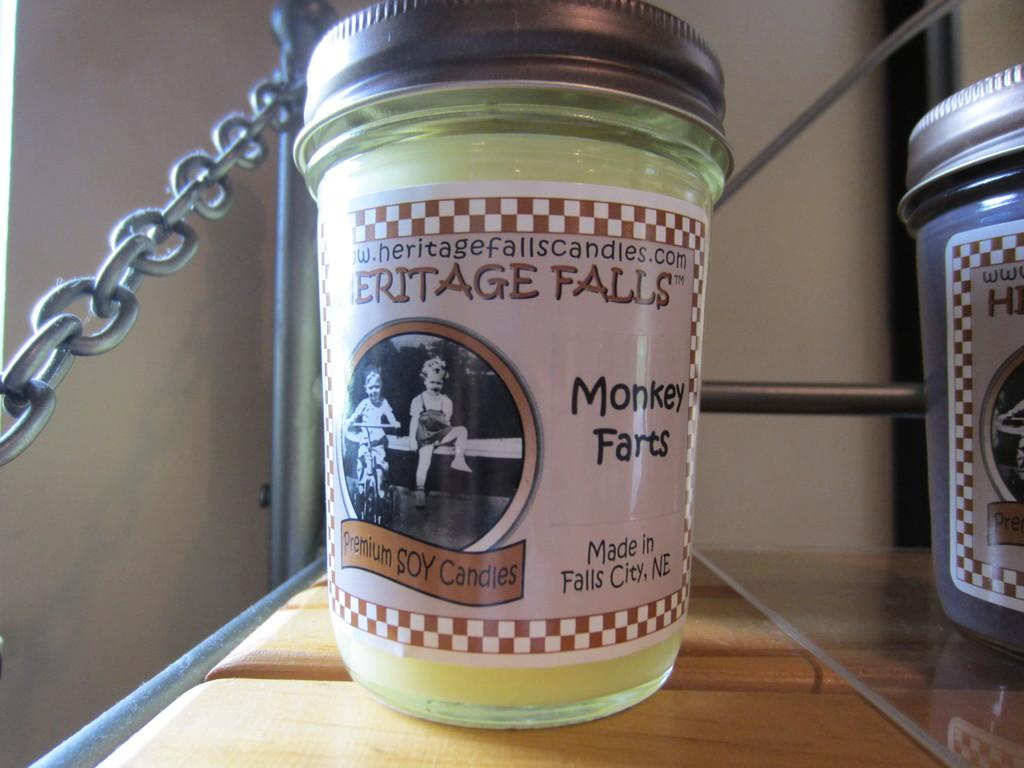Provide a one-sentence caption for the provided image. A Monkey Farts soy candle from Heritage Falls sits on a shelf. 